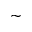Convert formula to latex. <formula><loc_0><loc_0><loc_500><loc_500>\sim</formula> 